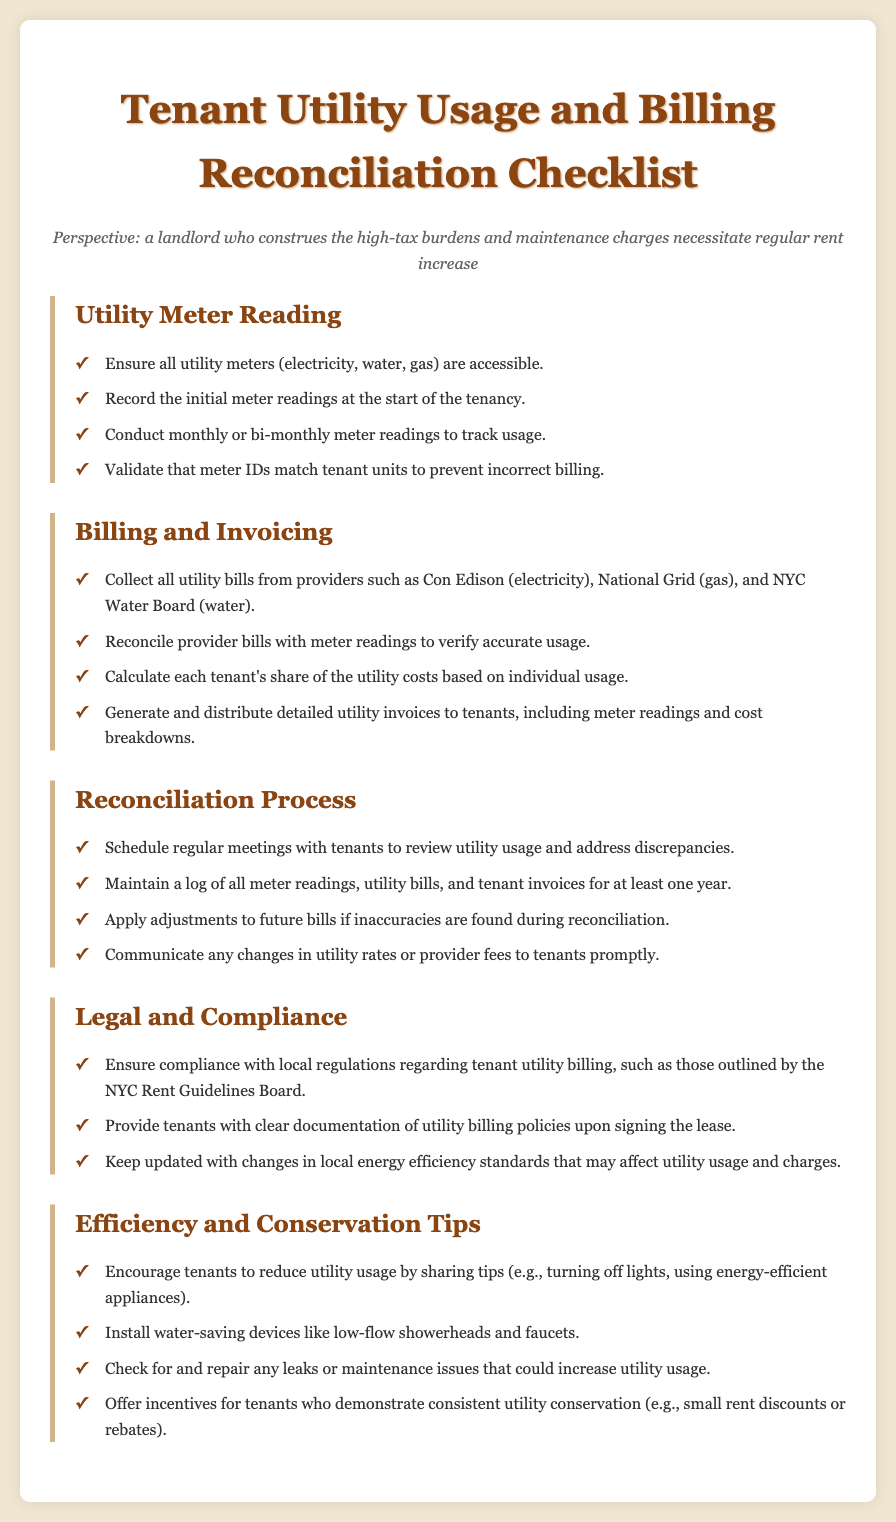what are the utility types listed in the checklist? The checklist mentions three specific utility types: electricity, water, and gas.
Answer: electricity, water, gas how often should meter readings be conducted? The document states that meter readings should be conducted monthly or bi-monthly.
Answer: monthly or bi-monthly who provides the electricity utility service? The checklist mentions Con Edison as the provider for electricity services.
Answer: Con Edison what is required to ensure accurate utility billing? The reconciliation process requires reconciling provider bills with meter readings to verify accurate usage.
Answer: reconcile provider bills with meter readings how long should utility records be maintained? The document specifies that a log of all meter readings, utility bills, and tenant invoices should be kept for at least one year.
Answer: one year what should tenants be encouraged to do to save utilities? The checklist suggests encouraging tenants to reduce utility usage by sharing conservation tips.
Answer: reduce utility usage what is a tip for water-saving installations? The checklist recommends installing low-flow showerheads and faucets as a water-saving device.
Answer: low-flow showerheads and faucets what legal compliance is mentioned regarding utility billing? The document highlights the need for compliance with local regulations, particularly those outlined by the NYC Rent Guidelines Board.
Answer: NYC Rent Guidelines Board 